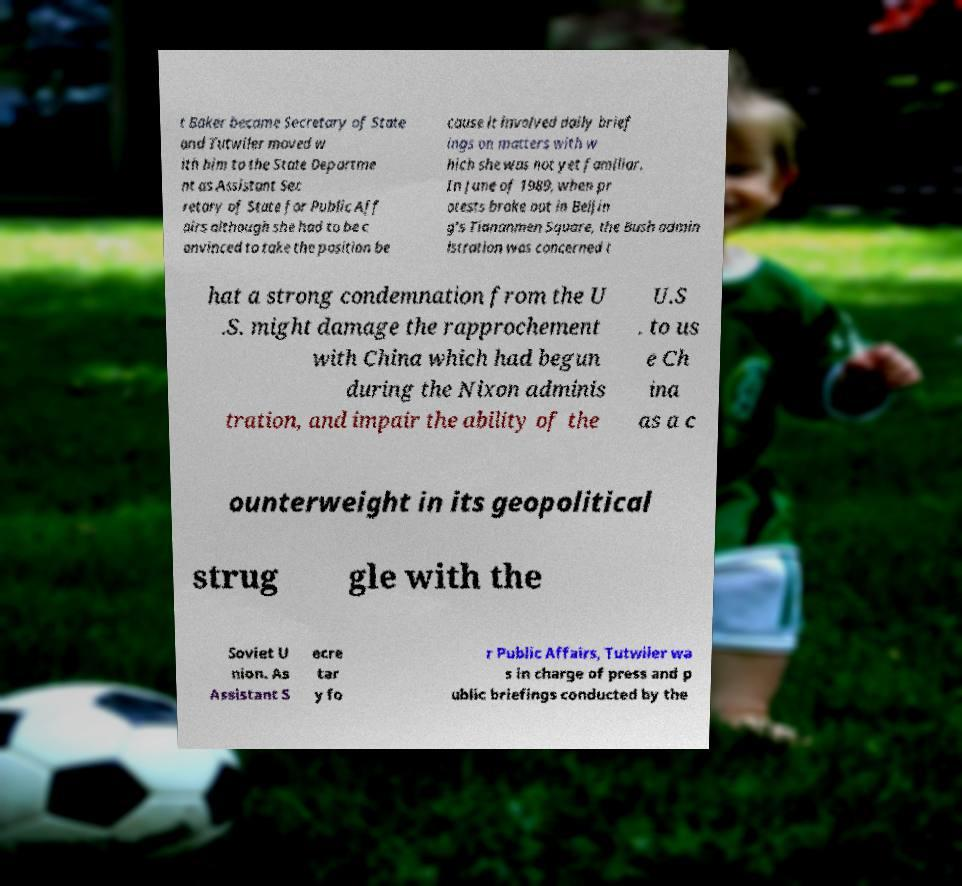Could you assist in decoding the text presented in this image and type it out clearly? t Baker became Secretary of State and Tutwiler moved w ith him to the State Departme nt as Assistant Sec retary of State for Public Aff airs although she had to be c onvinced to take the position be cause it involved daily brief ings on matters with w hich she was not yet familiar. In June of 1989, when pr otests broke out in Beijin g’s Tiananmen Square, the Bush admin istration was concerned t hat a strong condemnation from the U .S. might damage the rapprochement with China which had begun during the Nixon adminis tration, and impair the ability of the U.S . to us e Ch ina as a c ounterweight in its geopolitical strug gle with the Soviet U nion. As Assistant S ecre tar y fo r Public Affairs, Tutwiler wa s in charge of press and p ublic briefings conducted by the 